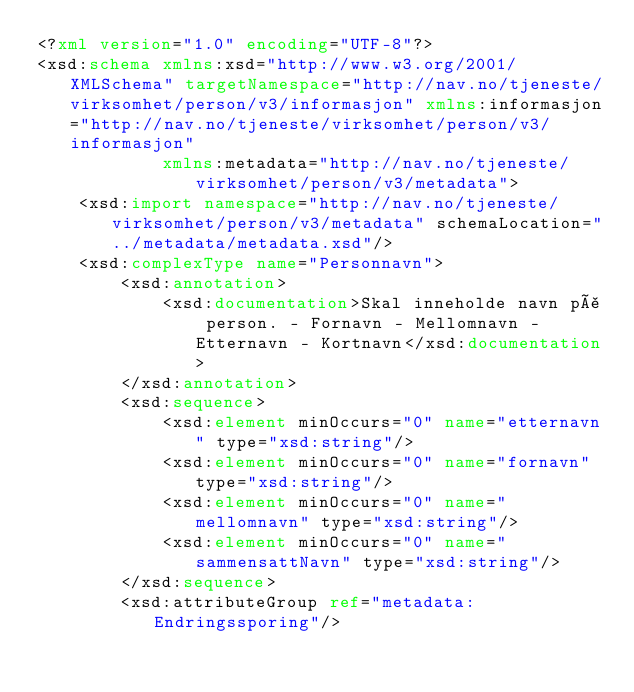Convert code to text. <code><loc_0><loc_0><loc_500><loc_500><_XML_><?xml version="1.0" encoding="UTF-8"?>
<xsd:schema xmlns:xsd="http://www.w3.org/2001/XMLSchema" targetNamespace="http://nav.no/tjeneste/virksomhet/person/v3/informasjon" xmlns:informasjon="http://nav.no/tjeneste/virksomhet/person/v3/informasjon"
            xmlns:metadata="http://nav.no/tjeneste/virksomhet/person/v3/metadata">
    <xsd:import namespace="http://nav.no/tjeneste/virksomhet/person/v3/metadata" schemaLocation="../metadata/metadata.xsd"/>
    <xsd:complexType name="Personnavn">
        <xsd:annotation>
            <xsd:documentation>Skal inneholde navn på person. - Fornavn - Mellomnavn - Etternavn - Kortnavn</xsd:documentation>
        </xsd:annotation>
        <xsd:sequence>
            <xsd:element minOccurs="0" name="etternavn" type="xsd:string"/>
            <xsd:element minOccurs="0" name="fornavn" type="xsd:string"/>
            <xsd:element minOccurs="0" name="mellomnavn" type="xsd:string"/>
            <xsd:element minOccurs="0" name="sammensattNavn" type="xsd:string"/>
        </xsd:sequence>
        <xsd:attributeGroup ref="metadata:Endringssporing"/></code> 